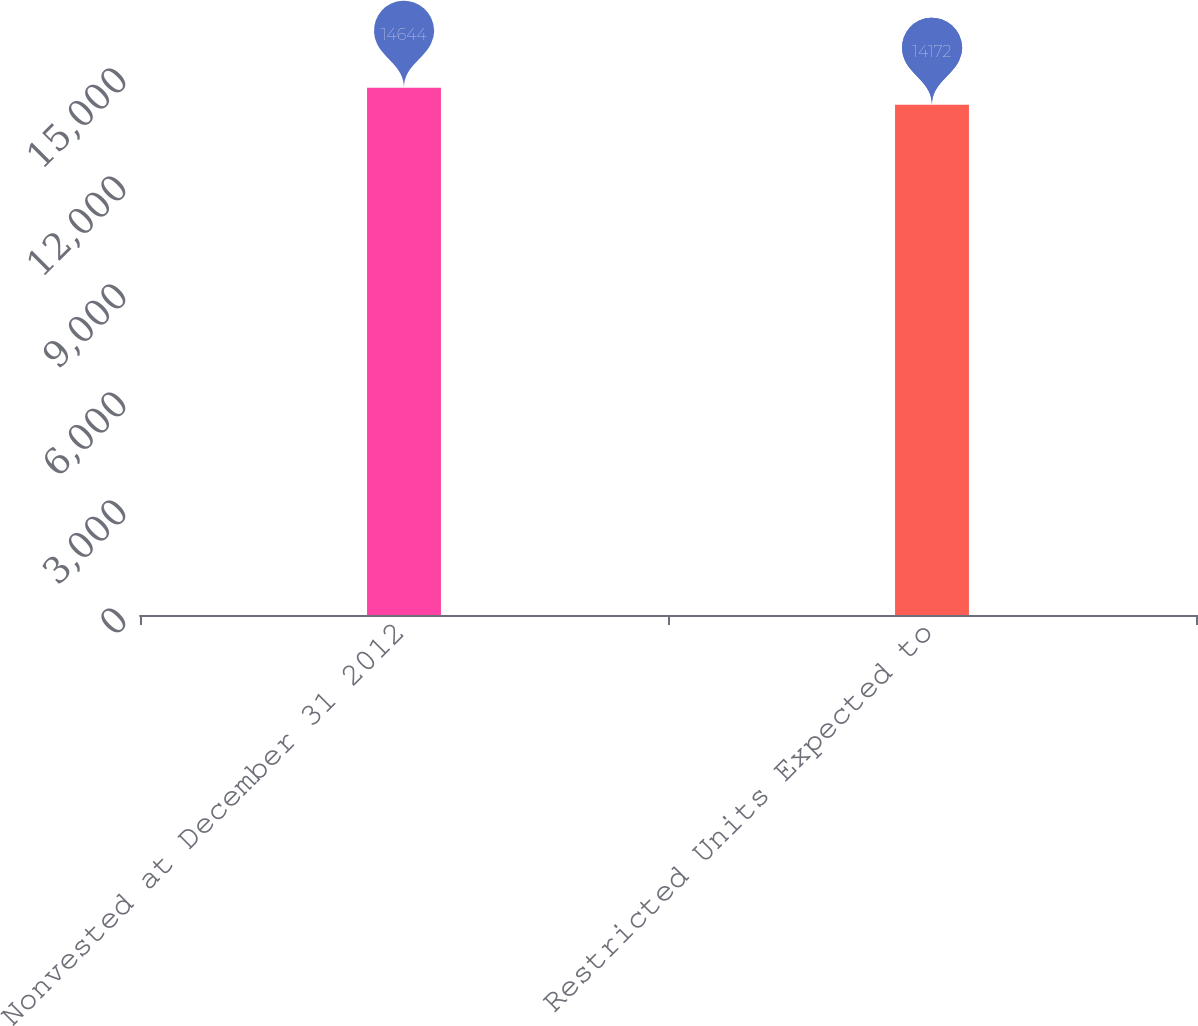<chart> <loc_0><loc_0><loc_500><loc_500><bar_chart><fcel>Nonvested at December 31 2012<fcel>Restricted Units Expected to<nl><fcel>14644<fcel>14172<nl></chart> 